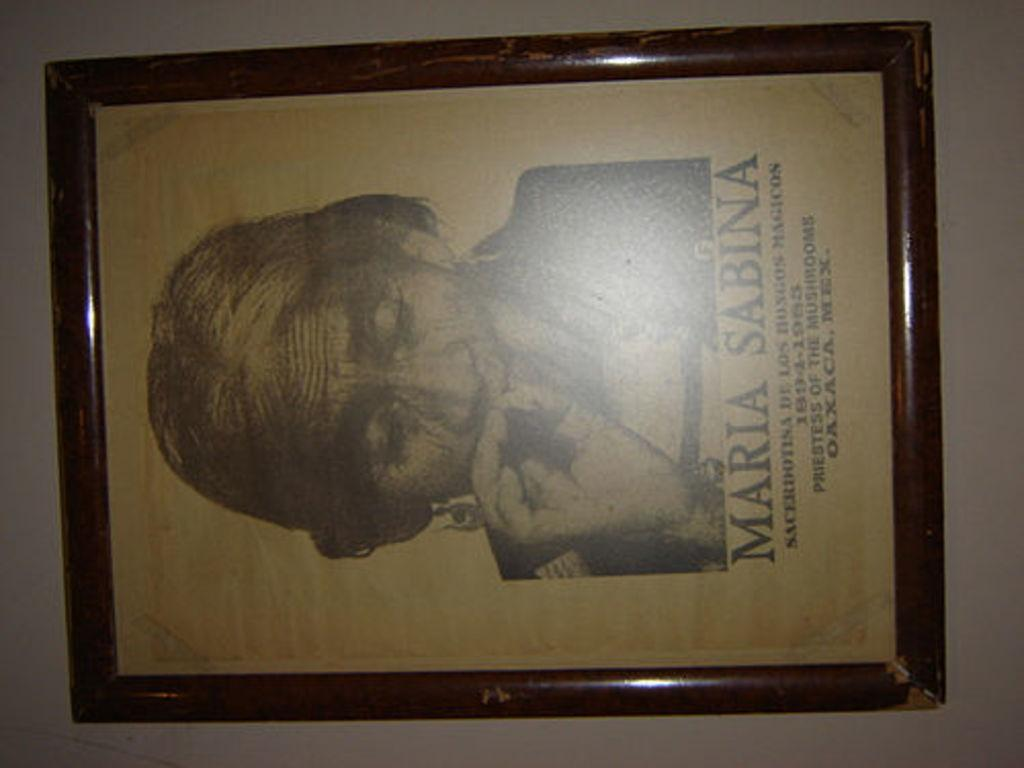What object is present in the image that typically holds a photograph? There is a photo frame in the image. How is the photo frame positioned in the image? The photo frame is in a vertical position. Who or what can be seen in the photo frame? There is a person in the photo frame. What additional information is provided below the person in the photo frame? There is some text below the person in the photo frame. What type of match is being played in the image? There is no match being played in the image; it features a photo frame with a person and text. How does the son contribute to the industry in the image? There is no son or industry present in the image. 